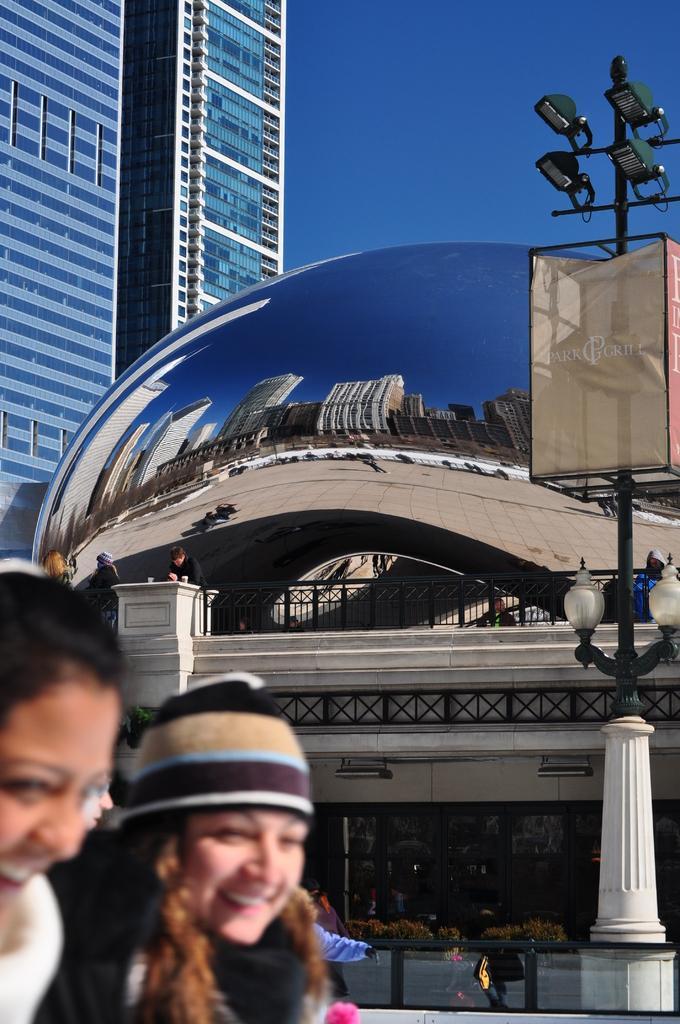Please provide a concise description of this image. At the bottom right corner there are women. In the background there is a building, light pole, persons and sky. 